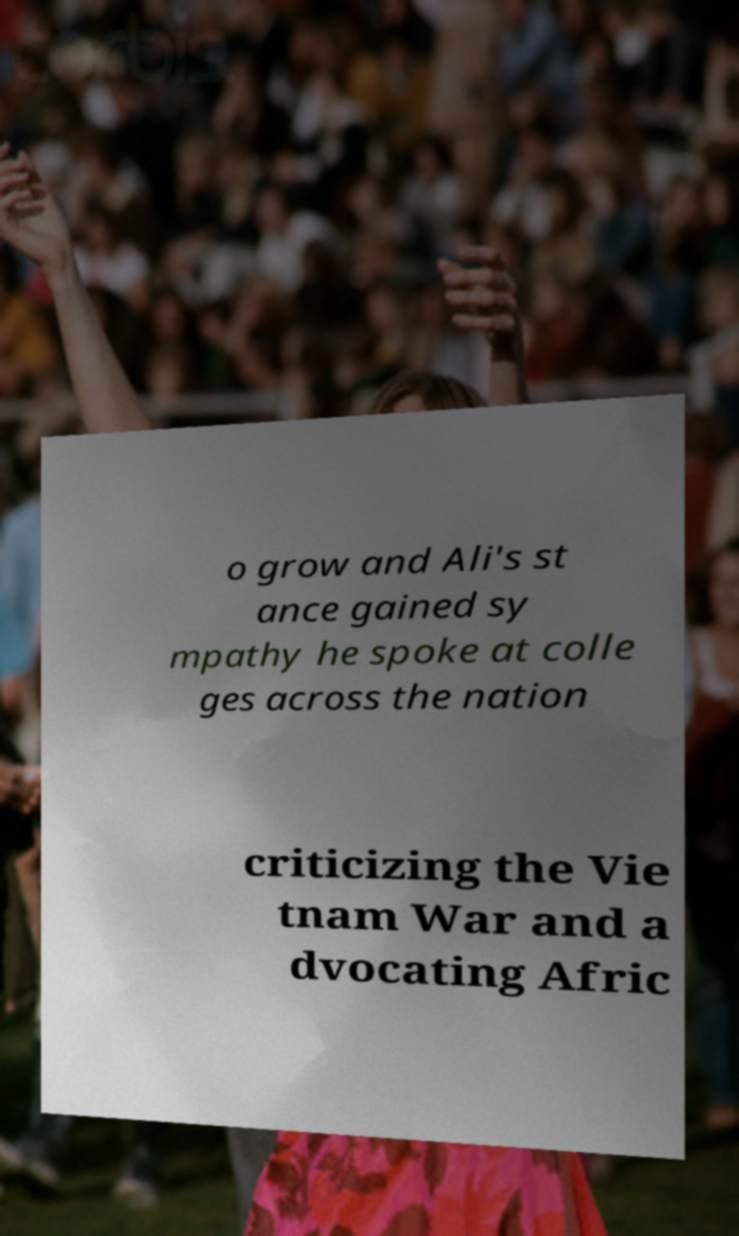Can you read and provide the text displayed in the image?This photo seems to have some interesting text. Can you extract and type it out for me? o grow and Ali's st ance gained sy mpathy he spoke at colle ges across the nation criticizing the Vie tnam War and a dvocating Afric 